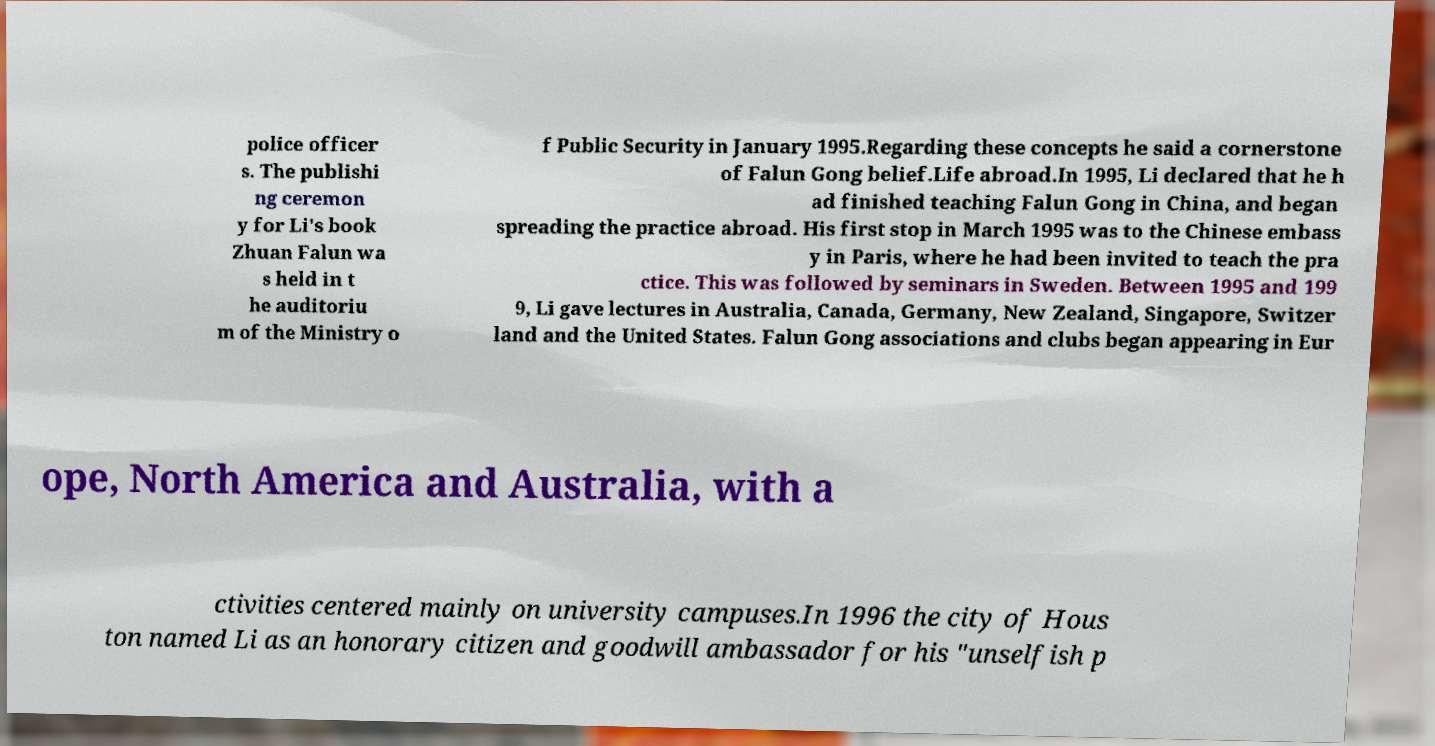Could you assist in decoding the text presented in this image and type it out clearly? police officer s. The publishi ng ceremon y for Li's book Zhuan Falun wa s held in t he auditoriu m of the Ministry o f Public Security in January 1995.Regarding these concepts he said a cornerstone of Falun Gong belief.Life abroad.In 1995, Li declared that he h ad finished teaching Falun Gong in China, and began spreading the practice abroad. His first stop in March 1995 was to the Chinese embass y in Paris, where he had been invited to teach the pra ctice. This was followed by seminars in Sweden. Between 1995 and 199 9, Li gave lectures in Australia, Canada, Germany, New Zealand, Singapore, Switzer land and the United States. Falun Gong associations and clubs began appearing in Eur ope, North America and Australia, with a ctivities centered mainly on university campuses.In 1996 the city of Hous ton named Li as an honorary citizen and goodwill ambassador for his "unselfish p 